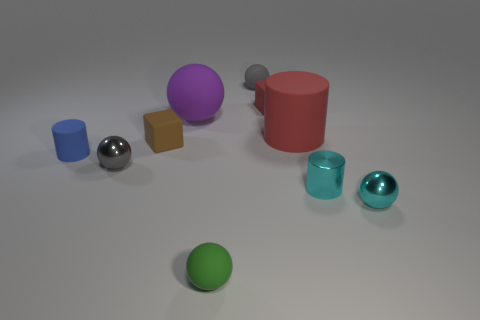Subtract all green balls. How many balls are left? 4 Subtract all large matte spheres. How many spheres are left? 4 Subtract all green balls. Subtract all green cylinders. How many balls are left? 4 Subtract all cylinders. How many objects are left? 7 Add 8 small red matte blocks. How many small red matte blocks exist? 9 Subtract 1 red cylinders. How many objects are left? 9 Subtract all tiny green matte balls. Subtract all small brown rubber things. How many objects are left? 8 Add 2 large red matte cylinders. How many large red matte cylinders are left? 3 